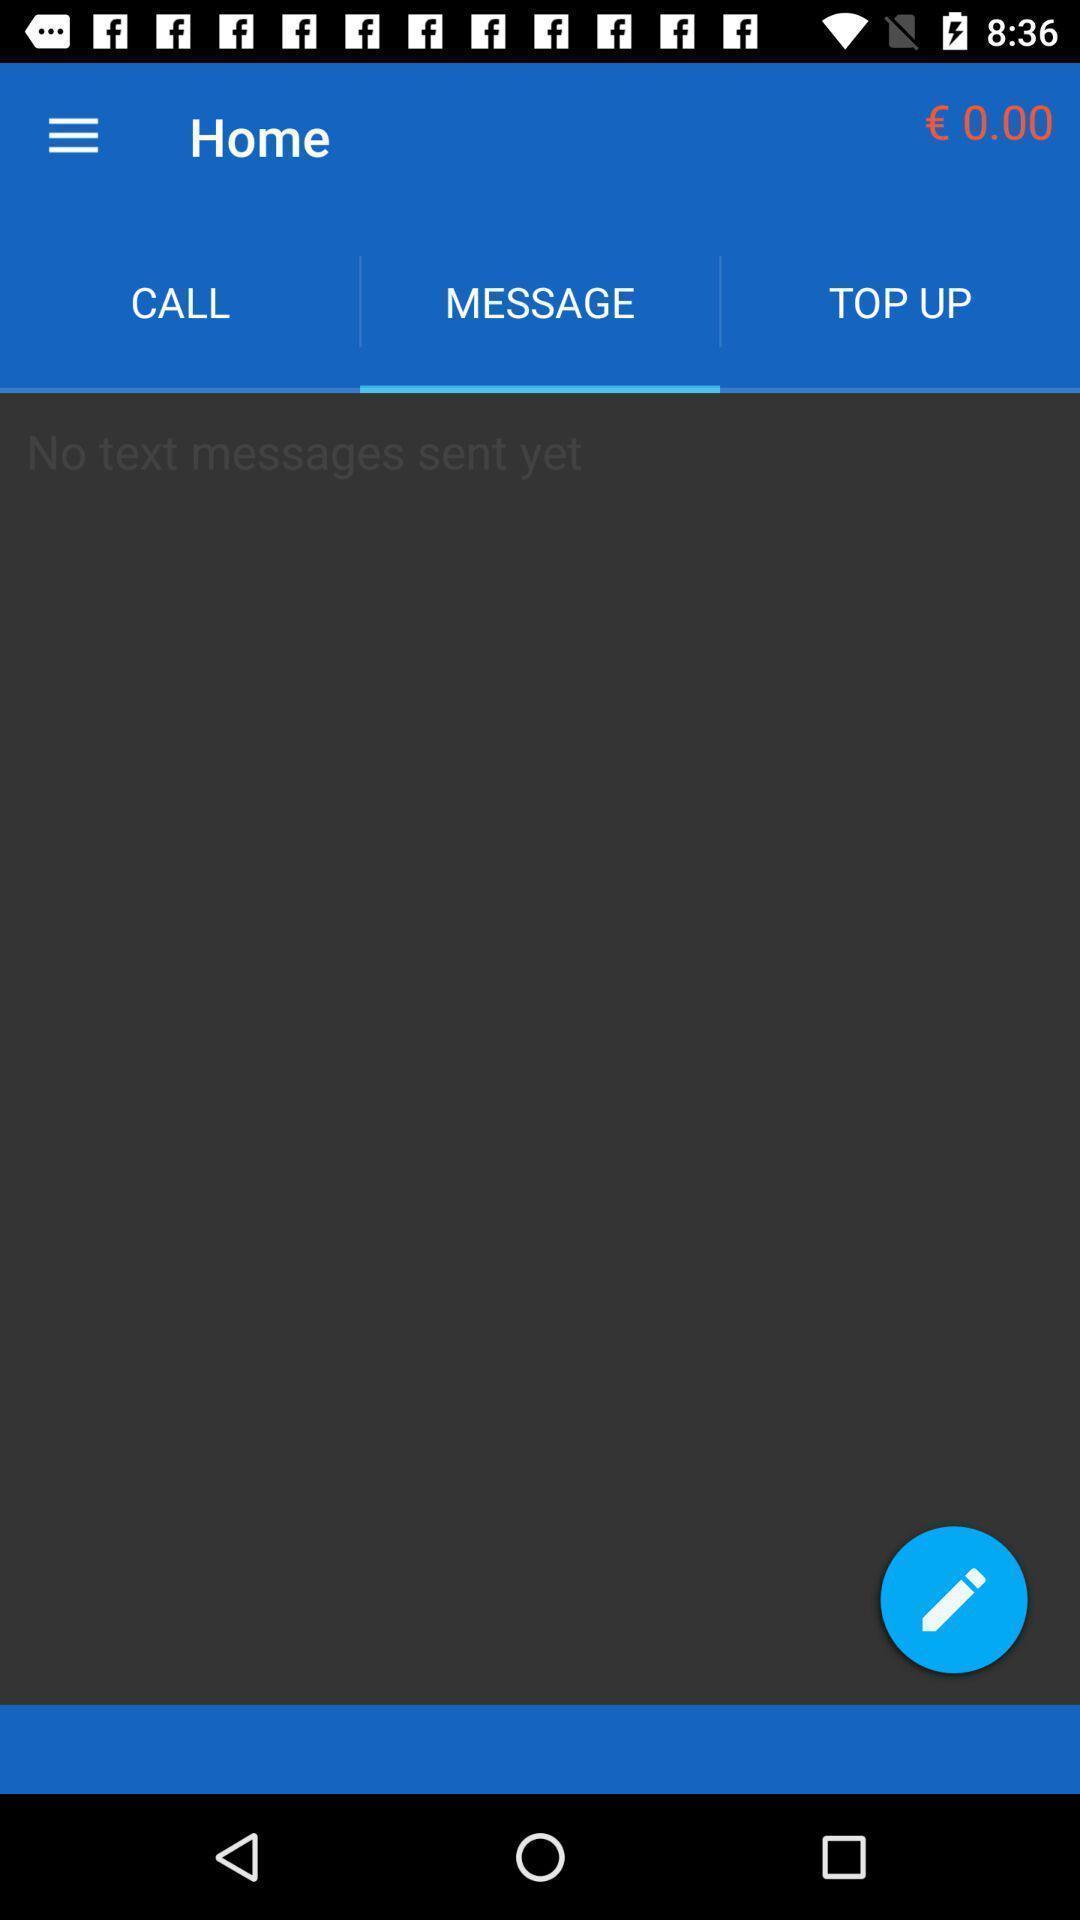Describe the content in this image. Screen showing home page with no messages. 